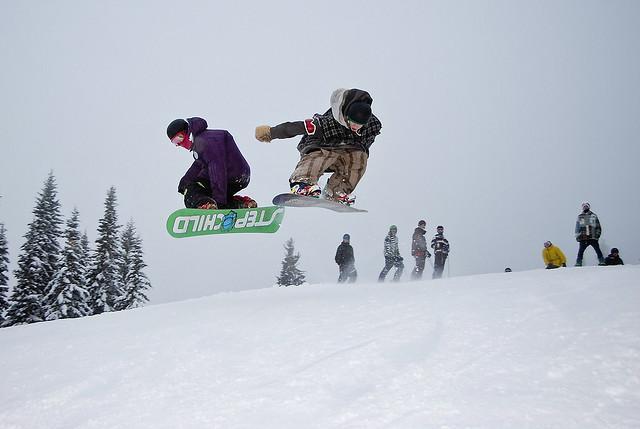How many people can be seen?
Give a very brief answer. 2. 